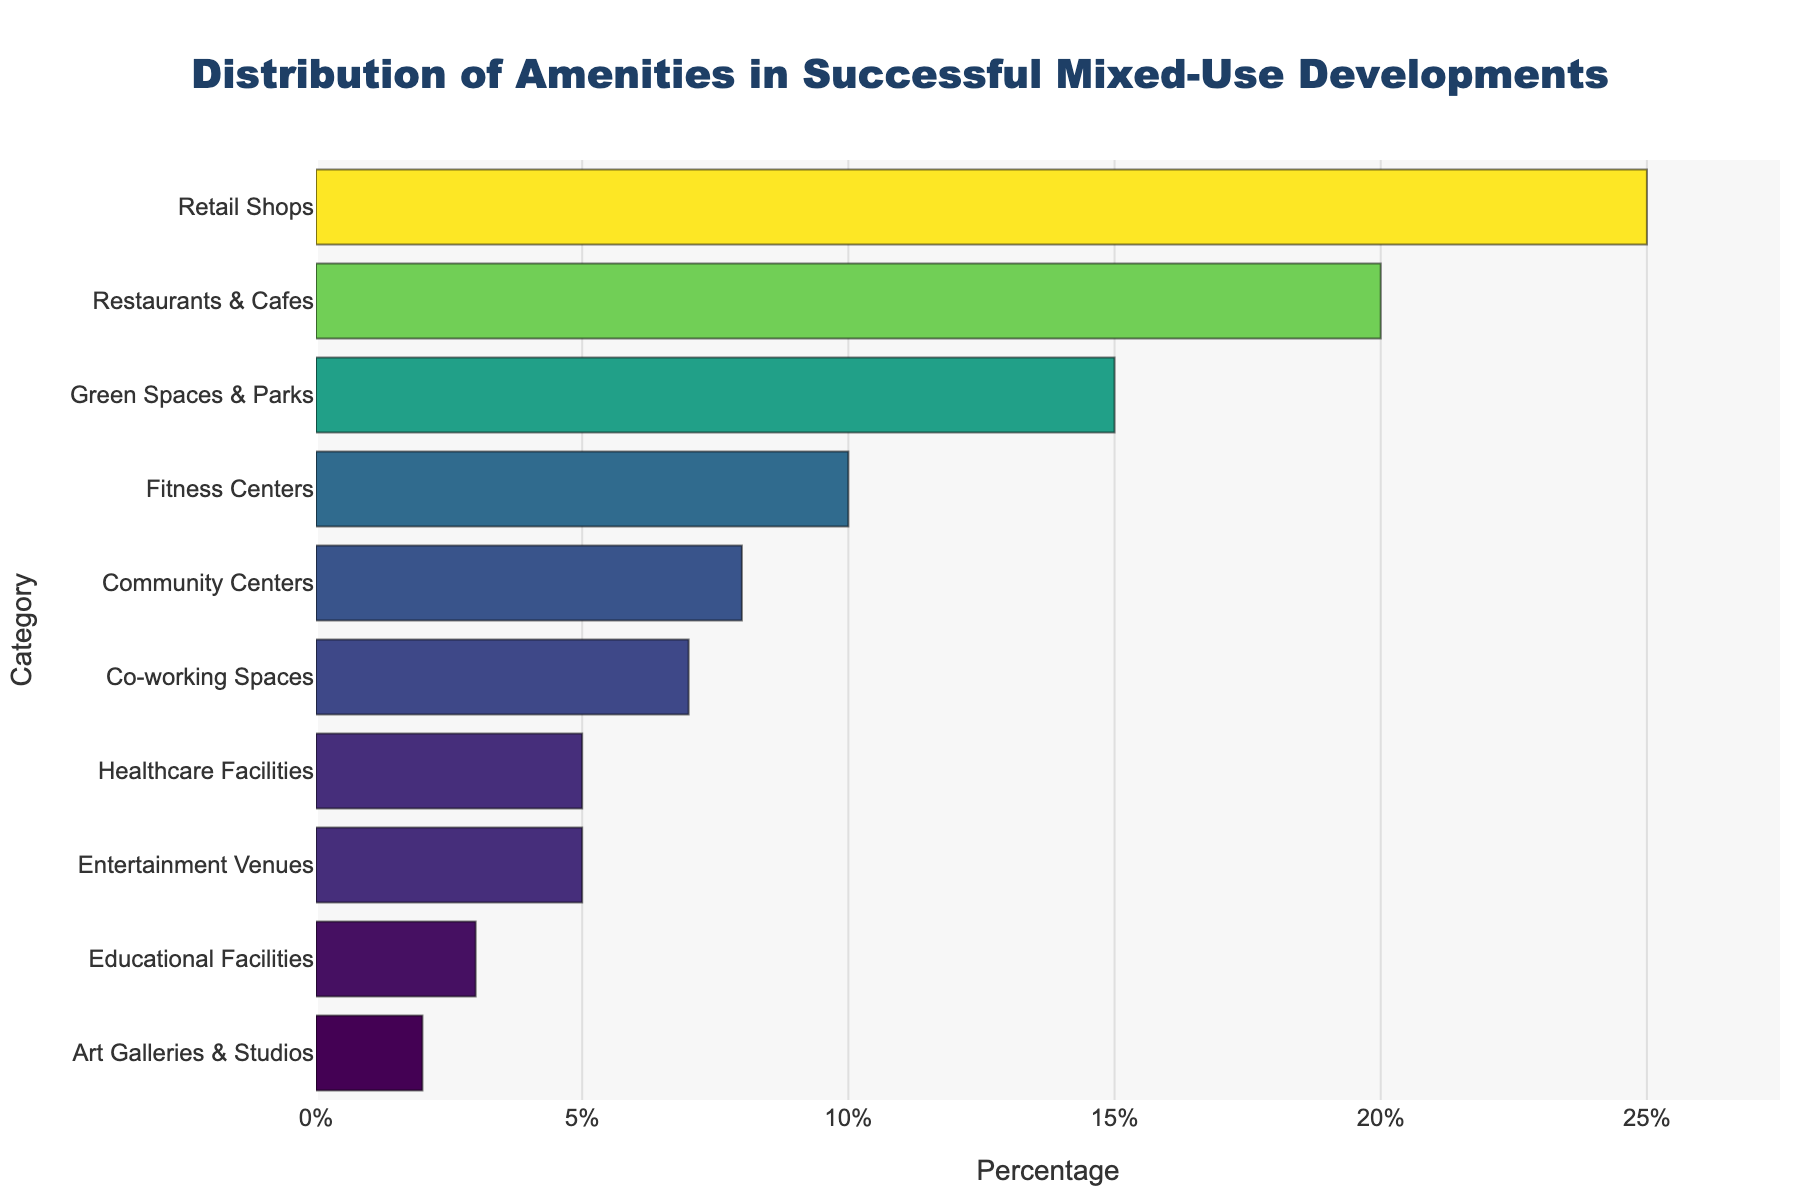Which category has the highest percentage of amenities? By looking at the bar chart, the category with the longest bar represents the highest percentage. The bar for "Retail Shops" is the longest, reaching 25%.
Answer: Retail Shops What's the combined percentage of Fitness Centers and Healthcare Facilities? The bar chart shows the percentages for Fitness Centers (10%) and Healthcare Facilities (5%). Adding these percentages together gives 10% + 5% = 15%.
Answer: 15% Compare the percentage of Green Spaces & Parks with Restaurants & Cafes. Which one is higher and by how much? The bar chart shows Green Spaces & Parks at 15% and Restaurants & Cafes at 20%. Restaurants & Cafes is higher by 20% - 15% = 5%.
Answer: Restaurants & Cafes, 5% Which category has the second smallest percentage of amenities? From the bar chart, we can see that "Art Galleries & Studios" has the smallest percentage at 2%. The next smallest bar is "Educational Facilities" with 3%.
Answer: Educational Facilities How does the percentage of Co-working Spaces compare to Community Centers? The bar chart lists Community Centers at 8% and Co-working Spaces at 7%. Community Centers have a higher percentage by 8% - 7% = 1%.
Answer: Community Centers, 1% What is the sum of the percentages of categories that have less than or equal to 10%? The categories with less than or equal to 10% are: Fitness Centers (10%), Community Centers (8%), Co-working Spaces (7%), Healthcare Facilities (5%), Entertainment Venues (5%), Educational Facilities (3%), and Art Galleries & Studios (2%). Summing these gives 10% + 8% + 7% + 5% + 5% + 3% + 2% = 40%.
Answer: 40% What is the average percentage of the three categories with the highest percentages? The top three categories, according to the bar chart, are Retail Shops (25%), Restaurants & Cafes (20%), and Green Spaces & Parks (15%). The average can be calculated as (25% + 20% + 15%) / 3 = 60% / 3 = 20%.
Answer: 20% Is there any category with exactly half the percentage of Retail Shops? Which one? Retail Shops have a percentage of 25%. Half of this is 12.5%. According to the bar chart, none of the categories have exactly 12.5%.
Answer: None What's the difference between the percentage of Educational Facilities and Art Galleries & Studios? From the bar chart, Educational Facilities are at 3% and Art Galleries & Studios are at 2%. The difference is 3% - 2% = 1%.
Answer: 1% Which category is visually represented by a bar colored differently from the others? By observing the color pattern in the bar chart, none of the categories are uniquely colored; all bars utilize a continuous colorscale without a unique standout color for a specific category.
Answer: None 